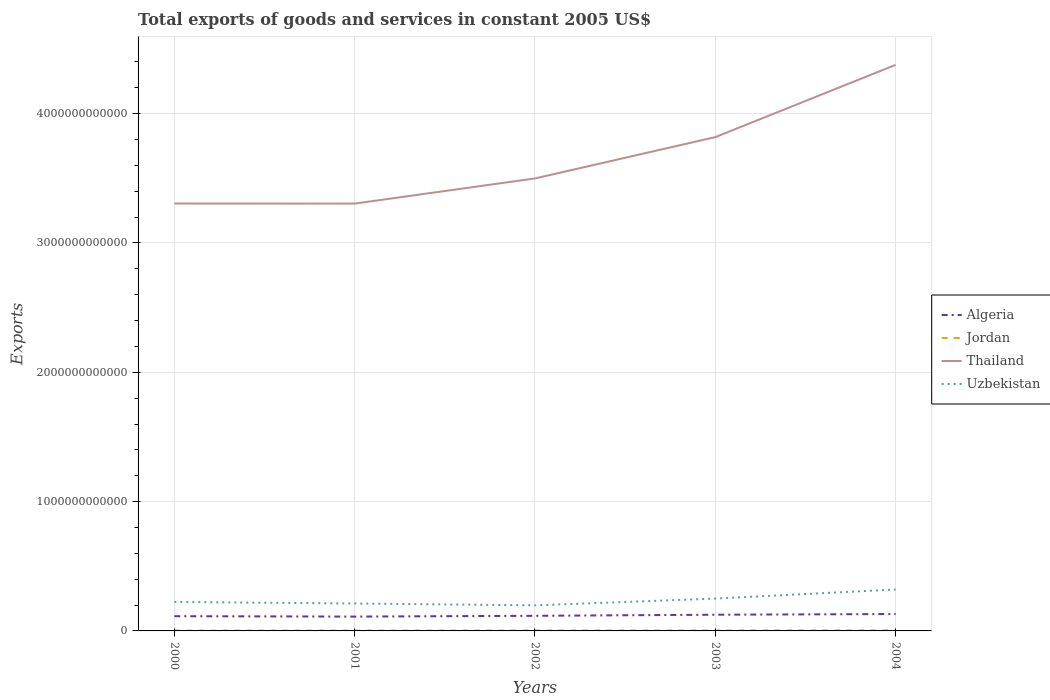Does the line corresponding to Thailand intersect with the line corresponding to Uzbekistan?
Provide a short and direct response. No. Across all years, what is the maximum total exports of goods and services in Uzbekistan?
Your response must be concise. 1.98e+11. In which year was the total exports of goods and services in Algeria maximum?
Keep it short and to the point. 2001. What is the total total exports of goods and services in Thailand in the graph?
Offer a very short reply. -1.94e+11. What is the difference between the highest and the second highest total exports of goods and services in Jordan?
Provide a succinct answer. 1.15e+09. How many lines are there?
Ensure brevity in your answer.  4. How many years are there in the graph?
Your response must be concise. 5. What is the difference between two consecutive major ticks on the Y-axis?
Your response must be concise. 1.00e+12. Are the values on the major ticks of Y-axis written in scientific E-notation?
Provide a succinct answer. No. How many legend labels are there?
Keep it short and to the point. 4. How are the legend labels stacked?
Give a very brief answer. Vertical. What is the title of the graph?
Your answer should be compact. Total exports of goods and services in constant 2005 US$. Does "Micronesia" appear as one of the legend labels in the graph?
Offer a terse response. No. What is the label or title of the X-axis?
Your answer should be very brief. Years. What is the label or title of the Y-axis?
Provide a succinct answer. Exports. What is the Exports in Algeria in 2000?
Your answer should be compact. 1.14e+11. What is the Exports in Jordan in 2000?
Offer a very short reply. 2.32e+09. What is the Exports of Thailand in 2000?
Your response must be concise. 3.31e+12. What is the Exports in Uzbekistan in 2000?
Offer a very short reply. 2.24e+11. What is the Exports in Algeria in 2001?
Keep it short and to the point. 1.11e+11. What is the Exports of Jordan in 2001?
Provide a succinct answer. 2.44e+09. What is the Exports of Thailand in 2001?
Your answer should be compact. 3.30e+12. What is the Exports in Uzbekistan in 2001?
Your answer should be very brief. 2.12e+11. What is the Exports of Algeria in 2002?
Offer a very short reply. 1.17e+11. What is the Exports of Jordan in 2002?
Offer a terse response. 2.88e+09. What is the Exports in Thailand in 2002?
Your answer should be very brief. 3.50e+12. What is the Exports in Uzbekistan in 2002?
Provide a short and direct response. 1.98e+11. What is the Exports of Algeria in 2003?
Make the answer very short. 1.25e+11. What is the Exports of Jordan in 2003?
Your answer should be compact. 3.03e+09. What is the Exports in Thailand in 2003?
Offer a very short reply. 3.82e+12. What is the Exports in Uzbekistan in 2003?
Your answer should be very brief. 2.50e+11. What is the Exports of Algeria in 2004?
Ensure brevity in your answer.  1.30e+11. What is the Exports in Jordan in 2004?
Offer a terse response. 3.47e+09. What is the Exports of Thailand in 2004?
Your response must be concise. 4.38e+12. What is the Exports of Uzbekistan in 2004?
Your response must be concise. 3.20e+11. Across all years, what is the maximum Exports of Algeria?
Provide a succinct answer. 1.30e+11. Across all years, what is the maximum Exports in Jordan?
Your answer should be compact. 3.47e+09. Across all years, what is the maximum Exports in Thailand?
Provide a succinct answer. 4.38e+12. Across all years, what is the maximum Exports of Uzbekistan?
Keep it short and to the point. 3.20e+11. Across all years, what is the minimum Exports in Algeria?
Ensure brevity in your answer.  1.11e+11. Across all years, what is the minimum Exports of Jordan?
Give a very brief answer. 2.32e+09. Across all years, what is the minimum Exports in Thailand?
Provide a short and direct response. 3.30e+12. Across all years, what is the minimum Exports in Uzbekistan?
Offer a terse response. 1.98e+11. What is the total Exports in Algeria in the graph?
Your answer should be very brief. 5.97e+11. What is the total Exports in Jordan in the graph?
Offer a very short reply. 1.41e+1. What is the total Exports of Thailand in the graph?
Make the answer very short. 1.83e+13. What is the total Exports in Uzbekistan in the graph?
Ensure brevity in your answer.  1.20e+12. What is the difference between the Exports of Algeria in 2000 and that in 2001?
Offer a terse response. 3.07e+09. What is the difference between the Exports of Jordan in 2000 and that in 2001?
Your response must be concise. -1.17e+08. What is the difference between the Exports in Thailand in 2000 and that in 2001?
Give a very brief answer. 6.74e+08. What is the difference between the Exports of Uzbekistan in 2000 and that in 2001?
Give a very brief answer. 1.21e+1. What is the difference between the Exports of Algeria in 2000 and that in 2002?
Offer a terse response. -3.02e+09. What is the difference between the Exports in Jordan in 2000 and that in 2002?
Offer a terse response. -5.63e+08. What is the difference between the Exports in Thailand in 2000 and that in 2002?
Provide a short and direct response. -1.94e+11. What is the difference between the Exports of Uzbekistan in 2000 and that in 2002?
Give a very brief answer. 2.64e+1. What is the difference between the Exports in Algeria in 2000 and that in 2003?
Provide a short and direct response. -1.14e+1. What is the difference between the Exports of Jordan in 2000 and that in 2003?
Provide a short and direct response. -7.08e+08. What is the difference between the Exports of Thailand in 2000 and that in 2003?
Your answer should be compact. -5.13e+11. What is the difference between the Exports of Uzbekistan in 2000 and that in 2003?
Ensure brevity in your answer.  -2.59e+1. What is the difference between the Exports in Algeria in 2000 and that in 2004?
Give a very brief answer. -1.66e+1. What is the difference between the Exports in Jordan in 2000 and that in 2004?
Ensure brevity in your answer.  -1.15e+09. What is the difference between the Exports in Thailand in 2000 and that in 2004?
Keep it short and to the point. -1.07e+12. What is the difference between the Exports of Uzbekistan in 2000 and that in 2004?
Your response must be concise. -9.63e+1. What is the difference between the Exports of Algeria in 2001 and that in 2002?
Your response must be concise. -6.09e+09. What is the difference between the Exports in Jordan in 2001 and that in 2002?
Your answer should be very brief. -4.46e+08. What is the difference between the Exports of Thailand in 2001 and that in 2002?
Ensure brevity in your answer.  -1.95e+11. What is the difference between the Exports in Uzbekistan in 2001 and that in 2002?
Offer a very short reply. 1.43e+1. What is the difference between the Exports of Algeria in 2001 and that in 2003?
Provide a succinct answer. -1.45e+1. What is the difference between the Exports of Jordan in 2001 and that in 2003?
Offer a terse response. -5.92e+08. What is the difference between the Exports of Thailand in 2001 and that in 2003?
Keep it short and to the point. -5.14e+11. What is the difference between the Exports of Uzbekistan in 2001 and that in 2003?
Give a very brief answer. -3.80e+1. What is the difference between the Exports in Algeria in 2001 and that in 2004?
Keep it short and to the point. -1.97e+1. What is the difference between the Exports of Jordan in 2001 and that in 2004?
Provide a short and direct response. -1.03e+09. What is the difference between the Exports in Thailand in 2001 and that in 2004?
Make the answer very short. -1.07e+12. What is the difference between the Exports in Uzbekistan in 2001 and that in 2004?
Keep it short and to the point. -1.08e+11. What is the difference between the Exports of Algeria in 2002 and that in 2003?
Give a very brief answer. -8.42e+09. What is the difference between the Exports of Jordan in 2002 and that in 2003?
Provide a short and direct response. -1.46e+08. What is the difference between the Exports of Thailand in 2002 and that in 2003?
Give a very brief answer. -3.20e+11. What is the difference between the Exports of Uzbekistan in 2002 and that in 2003?
Your answer should be compact. -5.23e+1. What is the difference between the Exports of Algeria in 2002 and that in 2004?
Give a very brief answer. -1.36e+1. What is the difference between the Exports in Jordan in 2002 and that in 2004?
Make the answer very short. -5.87e+08. What is the difference between the Exports in Thailand in 2002 and that in 2004?
Offer a terse response. -8.78e+11. What is the difference between the Exports in Uzbekistan in 2002 and that in 2004?
Your response must be concise. -1.23e+11. What is the difference between the Exports in Algeria in 2003 and that in 2004?
Offer a terse response. -5.14e+09. What is the difference between the Exports of Jordan in 2003 and that in 2004?
Your answer should be compact. -4.41e+08. What is the difference between the Exports in Thailand in 2003 and that in 2004?
Offer a very short reply. -5.59e+11. What is the difference between the Exports in Uzbekistan in 2003 and that in 2004?
Provide a succinct answer. -7.04e+1. What is the difference between the Exports in Algeria in 2000 and the Exports in Jordan in 2001?
Provide a succinct answer. 1.11e+11. What is the difference between the Exports in Algeria in 2000 and the Exports in Thailand in 2001?
Make the answer very short. -3.19e+12. What is the difference between the Exports in Algeria in 2000 and the Exports in Uzbekistan in 2001?
Provide a short and direct response. -9.82e+1. What is the difference between the Exports of Jordan in 2000 and the Exports of Thailand in 2001?
Your answer should be compact. -3.30e+12. What is the difference between the Exports in Jordan in 2000 and the Exports in Uzbekistan in 2001?
Ensure brevity in your answer.  -2.10e+11. What is the difference between the Exports of Thailand in 2000 and the Exports of Uzbekistan in 2001?
Your answer should be compact. 3.09e+12. What is the difference between the Exports in Algeria in 2000 and the Exports in Jordan in 2002?
Provide a short and direct response. 1.11e+11. What is the difference between the Exports of Algeria in 2000 and the Exports of Thailand in 2002?
Ensure brevity in your answer.  -3.39e+12. What is the difference between the Exports in Algeria in 2000 and the Exports in Uzbekistan in 2002?
Your response must be concise. -8.39e+1. What is the difference between the Exports in Jordan in 2000 and the Exports in Thailand in 2002?
Give a very brief answer. -3.50e+12. What is the difference between the Exports of Jordan in 2000 and the Exports of Uzbekistan in 2002?
Keep it short and to the point. -1.95e+11. What is the difference between the Exports of Thailand in 2000 and the Exports of Uzbekistan in 2002?
Your answer should be compact. 3.11e+12. What is the difference between the Exports of Algeria in 2000 and the Exports of Jordan in 2003?
Give a very brief answer. 1.11e+11. What is the difference between the Exports of Algeria in 2000 and the Exports of Thailand in 2003?
Your answer should be very brief. -3.70e+12. What is the difference between the Exports of Algeria in 2000 and the Exports of Uzbekistan in 2003?
Give a very brief answer. -1.36e+11. What is the difference between the Exports in Jordan in 2000 and the Exports in Thailand in 2003?
Your response must be concise. -3.82e+12. What is the difference between the Exports in Jordan in 2000 and the Exports in Uzbekistan in 2003?
Provide a short and direct response. -2.48e+11. What is the difference between the Exports in Thailand in 2000 and the Exports in Uzbekistan in 2003?
Give a very brief answer. 3.06e+12. What is the difference between the Exports of Algeria in 2000 and the Exports of Jordan in 2004?
Make the answer very short. 1.10e+11. What is the difference between the Exports in Algeria in 2000 and the Exports in Thailand in 2004?
Give a very brief answer. -4.26e+12. What is the difference between the Exports of Algeria in 2000 and the Exports of Uzbekistan in 2004?
Provide a short and direct response. -2.07e+11. What is the difference between the Exports in Jordan in 2000 and the Exports in Thailand in 2004?
Your answer should be compact. -4.37e+12. What is the difference between the Exports in Jordan in 2000 and the Exports in Uzbekistan in 2004?
Give a very brief answer. -3.18e+11. What is the difference between the Exports in Thailand in 2000 and the Exports in Uzbekistan in 2004?
Your response must be concise. 2.98e+12. What is the difference between the Exports of Algeria in 2001 and the Exports of Jordan in 2002?
Ensure brevity in your answer.  1.08e+11. What is the difference between the Exports of Algeria in 2001 and the Exports of Thailand in 2002?
Your response must be concise. -3.39e+12. What is the difference between the Exports of Algeria in 2001 and the Exports of Uzbekistan in 2002?
Provide a succinct answer. -8.69e+1. What is the difference between the Exports in Jordan in 2001 and the Exports in Thailand in 2002?
Make the answer very short. -3.50e+12. What is the difference between the Exports in Jordan in 2001 and the Exports in Uzbekistan in 2002?
Your response must be concise. -1.95e+11. What is the difference between the Exports in Thailand in 2001 and the Exports in Uzbekistan in 2002?
Your answer should be compact. 3.11e+12. What is the difference between the Exports of Algeria in 2001 and the Exports of Jordan in 2003?
Provide a succinct answer. 1.08e+11. What is the difference between the Exports of Algeria in 2001 and the Exports of Thailand in 2003?
Offer a very short reply. -3.71e+12. What is the difference between the Exports of Algeria in 2001 and the Exports of Uzbekistan in 2003?
Your answer should be very brief. -1.39e+11. What is the difference between the Exports of Jordan in 2001 and the Exports of Thailand in 2003?
Your response must be concise. -3.82e+12. What is the difference between the Exports of Jordan in 2001 and the Exports of Uzbekistan in 2003?
Offer a very short reply. -2.48e+11. What is the difference between the Exports of Thailand in 2001 and the Exports of Uzbekistan in 2003?
Ensure brevity in your answer.  3.05e+12. What is the difference between the Exports of Algeria in 2001 and the Exports of Jordan in 2004?
Provide a succinct answer. 1.07e+11. What is the difference between the Exports of Algeria in 2001 and the Exports of Thailand in 2004?
Make the answer very short. -4.27e+12. What is the difference between the Exports in Algeria in 2001 and the Exports in Uzbekistan in 2004?
Offer a terse response. -2.10e+11. What is the difference between the Exports of Jordan in 2001 and the Exports of Thailand in 2004?
Provide a succinct answer. -4.37e+12. What is the difference between the Exports in Jordan in 2001 and the Exports in Uzbekistan in 2004?
Make the answer very short. -3.18e+11. What is the difference between the Exports in Thailand in 2001 and the Exports in Uzbekistan in 2004?
Offer a terse response. 2.98e+12. What is the difference between the Exports of Algeria in 2002 and the Exports of Jordan in 2003?
Your answer should be compact. 1.14e+11. What is the difference between the Exports of Algeria in 2002 and the Exports of Thailand in 2003?
Your answer should be compact. -3.70e+12. What is the difference between the Exports in Algeria in 2002 and the Exports in Uzbekistan in 2003?
Make the answer very short. -1.33e+11. What is the difference between the Exports of Jordan in 2002 and the Exports of Thailand in 2003?
Offer a very short reply. -3.82e+12. What is the difference between the Exports in Jordan in 2002 and the Exports in Uzbekistan in 2003?
Your response must be concise. -2.47e+11. What is the difference between the Exports of Thailand in 2002 and the Exports of Uzbekistan in 2003?
Give a very brief answer. 3.25e+12. What is the difference between the Exports in Algeria in 2002 and the Exports in Jordan in 2004?
Offer a terse response. 1.13e+11. What is the difference between the Exports of Algeria in 2002 and the Exports of Thailand in 2004?
Your answer should be compact. -4.26e+12. What is the difference between the Exports in Algeria in 2002 and the Exports in Uzbekistan in 2004?
Give a very brief answer. -2.04e+11. What is the difference between the Exports of Jordan in 2002 and the Exports of Thailand in 2004?
Offer a terse response. -4.37e+12. What is the difference between the Exports in Jordan in 2002 and the Exports in Uzbekistan in 2004?
Your answer should be compact. -3.18e+11. What is the difference between the Exports in Thailand in 2002 and the Exports in Uzbekistan in 2004?
Give a very brief answer. 3.18e+12. What is the difference between the Exports in Algeria in 2003 and the Exports in Jordan in 2004?
Keep it short and to the point. 1.22e+11. What is the difference between the Exports in Algeria in 2003 and the Exports in Thailand in 2004?
Provide a succinct answer. -4.25e+12. What is the difference between the Exports in Algeria in 2003 and the Exports in Uzbekistan in 2004?
Make the answer very short. -1.95e+11. What is the difference between the Exports in Jordan in 2003 and the Exports in Thailand in 2004?
Offer a terse response. -4.37e+12. What is the difference between the Exports in Jordan in 2003 and the Exports in Uzbekistan in 2004?
Provide a succinct answer. -3.17e+11. What is the difference between the Exports in Thailand in 2003 and the Exports in Uzbekistan in 2004?
Ensure brevity in your answer.  3.50e+12. What is the average Exports in Algeria per year?
Your answer should be compact. 1.19e+11. What is the average Exports in Jordan per year?
Make the answer very short. 2.83e+09. What is the average Exports in Thailand per year?
Offer a very short reply. 3.66e+12. What is the average Exports of Uzbekistan per year?
Make the answer very short. 2.41e+11. In the year 2000, what is the difference between the Exports of Algeria and Exports of Jordan?
Provide a succinct answer. 1.12e+11. In the year 2000, what is the difference between the Exports in Algeria and Exports in Thailand?
Provide a succinct answer. -3.19e+12. In the year 2000, what is the difference between the Exports in Algeria and Exports in Uzbekistan?
Provide a short and direct response. -1.10e+11. In the year 2000, what is the difference between the Exports in Jordan and Exports in Thailand?
Keep it short and to the point. -3.30e+12. In the year 2000, what is the difference between the Exports in Jordan and Exports in Uzbekistan?
Provide a succinct answer. -2.22e+11. In the year 2000, what is the difference between the Exports in Thailand and Exports in Uzbekistan?
Ensure brevity in your answer.  3.08e+12. In the year 2001, what is the difference between the Exports of Algeria and Exports of Jordan?
Offer a very short reply. 1.08e+11. In the year 2001, what is the difference between the Exports in Algeria and Exports in Thailand?
Provide a succinct answer. -3.19e+12. In the year 2001, what is the difference between the Exports in Algeria and Exports in Uzbekistan?
Offer a terse response. -1.01e+11. In the year 2001, what is the difference between the Exports of Jordan and Exports of Thailand?
Give a very brief answer. -3.30e+12. In the year 2001, what is the difference between the Exports in Jordan and Exports in Uzbekistan?
Make the answer very short. -2.10e+11. In the year 2001, what is the difference between the Exports in Thailand and Exports in Uzbekistan?
Provide a short and direct response. 3.09e+12. In the year 2002, what is the difference between the Exports of Algeria and Exports of Jordan?
Give a very brief answer. 1.14e+11. In the year 2002, what is the difference between the Exports in Algeria and Exports in Thailand?
Provide a succinct answer. -3.38e+12. In the year 2002, what is the difference between the Exports in Algeria and Exports in Uzbekistan?
Give a very brief answer. -8.08e+1. In the year 2002, what is the difference between the Exports in Jordan and Exports in Thailand?
Provide a short and direct response. -3.50e+12. In the year 2002, what is the difference between the Exports of Jordan and Exports of Uzbekistan?
Give a very brief answer. -1.95e+11. In the year 2002, what is the difference between the Exports in Thailand and Exports in Uzbekistan?
Give a very brief answer. 3.30e+12. In the year 2003, what is the difference between the Exports of Algeria and Exports of Jordan?
Offer a terse response. 1.22e+11. In the year 2003, what is the difference between the Exports in Algeria and Exports in Thailand?
Keep it short and to the point. -3.69e+12. In the year 2003, what is the difference between the Exports of Algeria and Exports of Uzbekistan?
Give a very brief answer. -1.25e+11. In the year 2003, what is the difference between the Exports in Jordan and Exports in Thailand?
Your response must be concise. -3.82e+12. In the year 2003, what is the difference between the Exports in Jordan and Exports in Uzbekistan?
Ensure brevity in your answer.  -2.47e+11. In the year 2003, what is the difference between the Exports of Thailand and Exports of Uzbekistan?
Your answer should be very brief. 3.57e+12. In the year 2004, what is the difference between the Exports in Algeria and Exports in Jordan?
Offer a terse response. 1.27e+11. In the year 2004, what is the difference between the Exports of Algeria and Exports of Thailand?
Your answer should be very brief. -4.25e+12. In the year 2004, what is the difference between the Exports in Algeria and Exports in Uzbekistan?
Provide a succinct answer. -1.90e+11. In the year 2004, what is the difference between the Exports in Jordan and Exports in Thailand?
Offer a very short reply. -4.37e+12. In the year 2004, what is the difference between the Exports in Jordan and Exports in Uzbekistan?
Provide a succinct answer. -3.17e+11. In the year 2004, what is the difference between the Exports in Thailand and Exports in Uzbekistan?
Your answer should be very brief. 4.06e+12. What is the ratio of the Exports in Algeria in 2000 to that in 2001?
Your response must be concise. 1.03. What is the ratio of the Exports of Jordan in 2000 to that in 2001?
Your answer should be compact. 0.95. What is the ratio of the Exports of Thailand in 2000 to that in 2001?
Your answer should be very brief. 1. What is the ratio of the Exports in Uzbekistan in 2000 to that in 2001?
Your response must be concise. 1.06. What is the ratio of the Exports of Algeria in 2000 to that in 2002?
Keep it short and to the point. 0.97. What is the ratio of the Exports in Jordan in 2000 to that in 2002?
Provide a short and direct response. 0.81. What is the ratio of the Exports of Thailand in 2000 to that in 2002?
Your answer should be very brief. 0.94. What is the ratio of the Exports of Uzbekistan in 2000 to that in 2002?
Your answer should be compact. 1.13. What is the ratio of the Exports in Algeria in 2000 to that in 2003?
Ensure brevity in your answer.  0.91. What is the ratio of the Exports of Jordan in 2000 to that in 2003?
Provide a short and direct response. 0.77. What is the ratio of the Exports of Thailand in 2000 to that in 2003?
Ensure brevity in your answer.  0.87. What is the ratio of the Exports of Uzbekistan in 2000 to that in 2003?
Ensure brevity in your answer.  0.9. What is the ratio of the Exports of Algeria in 2000 to that in 2004?
Offer a terse response. 0.87. What is the ratio of the Exports of Jordan in 2000 to that in 2004?
Your answer should be compact. 0.67. What is the ratio of the Exports in Thailand in 2000 to that in 2004?
Offer a very short reply. 0.76. What is the ratio of the Exports in Uzbekistan in 2000 to that in 2004?
Offer a terse response. 0.7. What is the ratio of the Exports of Algeria in 2001 to that in 2002?
Your response must be concise. 0.95. What is the ratio of the Exports in Jordan in 2001 to that in 2002?
Your answer should be compact. 0.85. What is the ratio of the Exports in Uzbekistan in 2001 to that in 2002?
Your answer should be compact. 1.07. What is the ratio of the Exports in Algeria in 2001 to that in 2003?
Offer a very short reply. 0.88. What is the ratio of the Exports in Jordan in 2001 to that in 2003?
Offer a terse response. 0.8. What is the ratio of the Exports in Thailand in 2001 to that in 2003?
Give a very brief answer. 0.87. What is the ratio of the Exports of Uzbekistan in 2001 to that in 2003?
Offer a very short reply. 0.85. What is the ratio of the Exports of Algeria in 2001 to that in 2004?
Make the answer very short. 0.85. What is the ratio of the Exports of Jordan in 2001 to that in 2004?
Provide a short and direct response. 0.7. What is the ratio of the Exports of Thailand in 2001 to that in 2004?
Offer a very short reply. 0.75. What is the ratio of the Exports in Uzbekistan in 2001 to that in 2004?
Ensure brevity in your answer.  0.66. What is the ratio of the Exports in Algeria in 2002 to that in 2003?
Make the answer very short. 0.93. What is the ratio of the Exports of Jordan in 2002 to that in 2003?
Provide a short and direct response. 0.95. What is the ratio of the Exports in Thailand in 2002 to that in 2003?
Your response must be concise. 0.92. What is the ratio of the Exports of Uzbekistan in 2002 to that in 2003?
Offer a very short reply. 0.79. What is the ratio of the Exports of Algeria in 2002 to that in 2004?
Your answer should be compact. 0.9. What is the ratio of the Exports in Jordan in 2002 to that in 2004?
Provide a succinct answer. 0.83. What is the ratio of the Exports in Thailand in 2002 to that in 2004?
Give a very brief answer. 0.8. What is the ratio of the Exports in Uzbekistan in 2002 to that in 2004?
Your response must be concise. 0.62. What is the ratio of the Exports of Algeria in 2003 to that in 2004?
Provide a short and direct response. 0.96. What is the ratio of the Exports in Jordan in 2003 to that in 2004?
Offer a very short reply. 0.87. What is the ratio of the Exports in Thailand in 2003 to that in 2004?
Ensure brevity in your answer.  0.87. What is the ratio of the Exports of Uzbekistan in 2003 to that in 2004?
Provide a succinct answer. 0.78. What is the difference between the highest and the second highest Exports in Algeria?
Keep it short and to the point. 5.14e+09. What is the difference between the highest and the second highest Exports in Jordan?
Give a very brief answer. 4.41e+08. What is the difference between the highest and the second highest Exports in Thailand?
Make the answer very short. 5.59e+11. What is the difference between the highest and the second highest Exports of Uzbekistan?
Provide a succinct answer. 7.04e+1. What is the difference between the highest and the lowest Exports of Algeria?
Your response must be concise. 1.97e+1. What is the difference between the highest and the lowest Exports of Jordan?
Give a very brief answer. 1.15e+09. What is the difference between the highest and the lowest Exports of Thailand?
Make the answer very short. 1.07e+12. What is the difference between the highest and the lowest Exports of Uzbekistan?
Your answer should be very brief. 1.23e+11. 